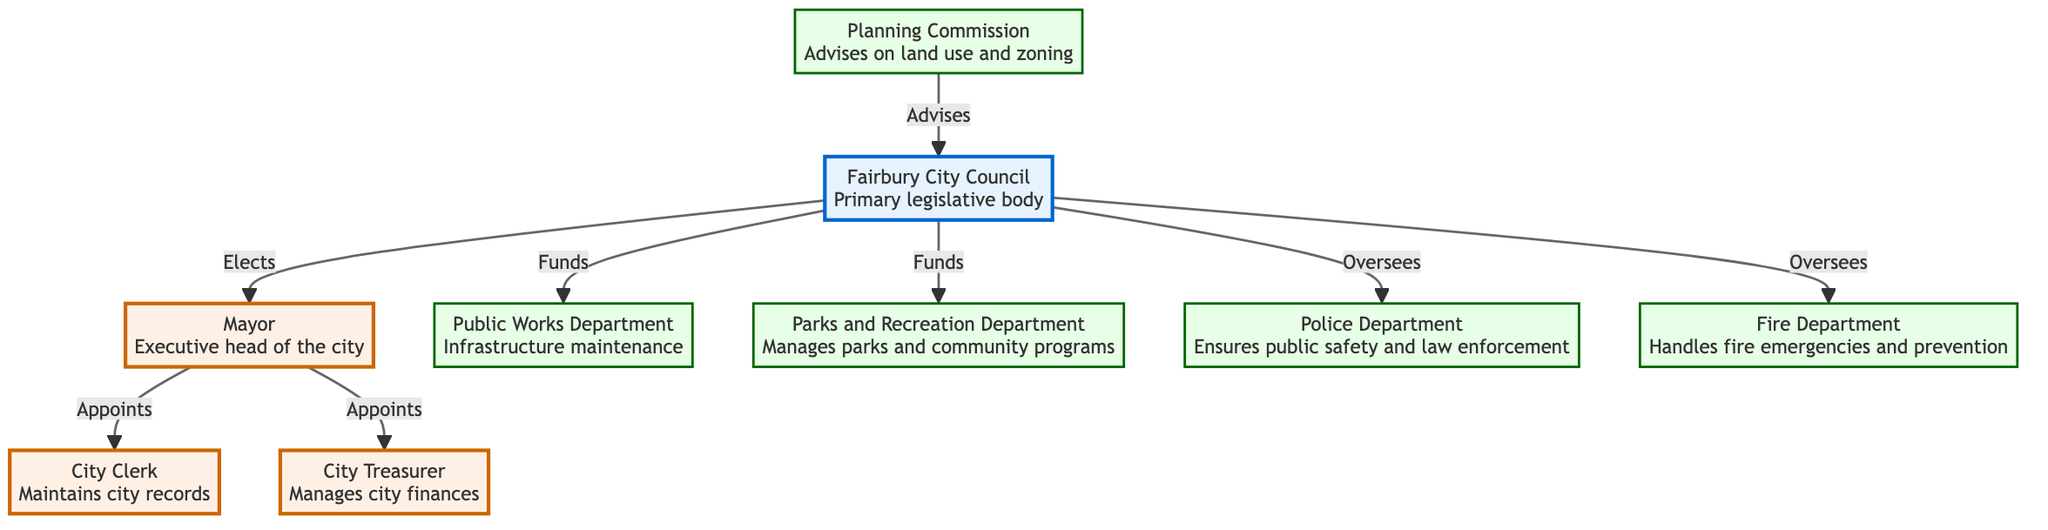What is the primary legislative body of Fairbury? The diagram indicates that the Fairbury City Council is depicted as the primary legislative body. This information is clearly stated within the node connected to the label.
Answer: Fairbury City Council Who appoints the City Clerk? The diagram shows a direct line from the Mayor to the City Clerk, indicating that the Mayor has the authority to appoint the City Clerk.
Answer: Mayor How many departments are listed in the diagram? Counting the nodes specifically labeled as departments (Public Works, Parks and Recreation, Police, Fire, and Planning Commission), there are five departments represented in the flowchart.
Answer: 5 Which department manages parks and community programs? From the diagram, it is clear that the Parks and Recreation Department is responsible for managing parks and community programs, as indicated in the department node.
Answer: Parks and Recreation Department What role does the Planning Commission play in the local government? The diagram shows that the Planning Commission advises the Fairbury City Council on land use and zoning matters, illustrating its advisory function clearly.
Answer: Advises What legislative body funds the Public Works Department? The Fairbury City Council is the body that funds the Public Works Department, as indicated by the labeled arrow connecting these two nodes.
Answer: Fairbury City Council How does the Mayor relate to the City Treasurer? The diagram demonstrates that the Mayor appoints the City Treasurer, thus establishing a direct relationship between these two entities within the local government structure.
Answer: Appoints Which department is responsible for ensuring public safety? According to the diagram, the Police Department is the entity responsible for ensuring public safety and law enforcement in Fairbury, as outlined in its description.
Answer: Police Department What is the Mayor's role in the local government? The diagram specifies that the Mayor serves as the executive head of the city, indicating their position in the local government structure and their primary responsibilities.
Answer: Executive head of the city 